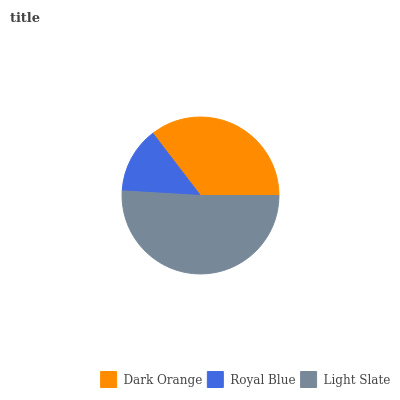Is Royal Blue the minimum?
Answer yes or no. Yes. Is Light Slate the maximum?
Answer yes or no. Yes. Is Light Slate the minimum?
Answer yes or no. No. Is Royal Blue the maximum?
Answer yes or no. No. Is Light Slate greater than Royal Blue?
Answer yes or no. Yes. Is Royal Blue less than Light Slate?
Answer yes or no. Yes. Is Royal Blue greater than Light Slate?
Answer yes or no. No. Is Light Slate less than Royal Blue?
Answer yes or no. No. Is Dark Orange the high median?
Answer yes or no. Yes. Is Dark Orange the low median?
Answer yes or no. Yes. Is Light Slate the high median?
Answer yes or no. No. Is Royal Blue the low median?
Answer yes or no. No. 